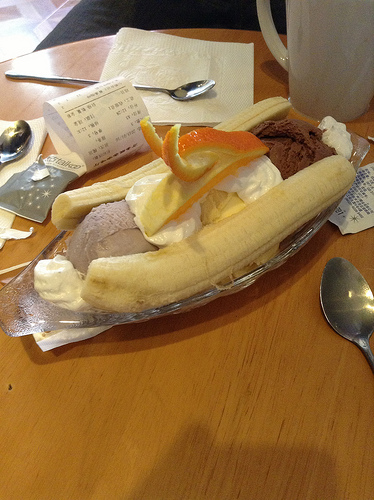<image>
Is there a ice cream behind the banana? Yes. From this viewpoint, the ice cream is positioned behind the banana, with the banana partially or fully occluding the ice cream. Is the orange on the banana? No. The orange is not positioned on the banana. They may be near each other, but the orange is not supported by or resting on top of the banana. 